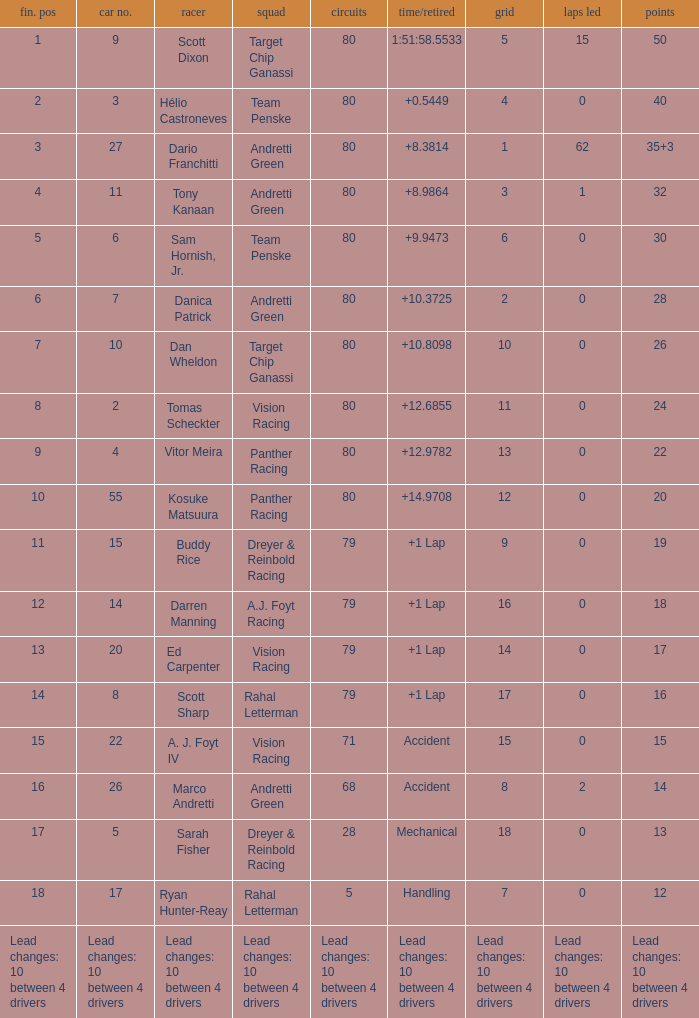How many laps does driver dario franchitti have? 80.0. Would you mind parsing the complete table? {'header': ['fin. pos', 'car no.', 'racer', 'squad', 'circuits', 'time/retired', 'grid', 'laps led', 'points'], 'rows': [['1', '9', 'Scott Dixon', 'Target Chip Ganassi', '80', '1:51:58.5533', '5', '15', '50'], ['2', '3', 'Hélio Castroneves', 'Team Penske', '80', '+0.5449', '4', '0', '40'], ['3', '27', 'Dario Franchitti', 'Andretti Green', '80', '+8.3814', '1', '62', '35+3'], ['4', '11', 'Tony Kanaan', 'Andretti Green', '80', '+8.9864', '3', '1', '32'], ['5', '6', 'Sam Hornish, Jr.', 'Team Penske', '80', '+9.9473', '6', '0', '30'], ['6', '7', 'Danica Patrick', 'Andretti Green', '80', '+10.3725', '2', '0', '28'], ['7', '10', 'Dan Wheldon', 'Target Chip Ganassi', '80', '+10.8098', '10', '0', '26'], ['8', '2', 'Tomas Scheckter', 'Vision Racing', '80', '+12.6855', '11', '0', '24'], ['9', '4', 'Vitor Meira', 'Panther Racing', '80', '+12.9782', '13', '0', '22'], ['10', '55', 'Kosuke Matsuura', 'Panther Racing', '80', '+14.9708', '12', '0', '20'], ['11', '15', 'Buddy Rice', 'Dreyer & Reinbold Racing', '79', '+1 Lap', '9', '0', '19'], ['12', '14', 'Darren Manning', 'A.J. Foyt Racing', '79', '+1 Lap', '16', '0', '18'], ['13', '20', 'Ed Carpenter', 'Vision Racing', '79', '+1 Lap', '14', '0', '17'], ['14', '8', 'Scott Sharp', 'Rahal Letterman', '79', '+1 Lap', '17', '0', '16'], ['15', '22', 'A. J. Foyt IV', 'Vision Racing', '71', 'Accident', '15', '0', '15'], ['16', '26', 'Marco Andretti', 'Andretti Green', '68', 'Accident', '8', '2', '14'], ['17', '5', 'Sarah Fisher', 'Dreyer & Reinbold Racing', '28', 'Mechanical', '18', '0', '13'], ['18', '17', 'Ryan Hunter-Reay', 'Rahal Letterman', '5', 'Handling', '7', '0', '12'], ['Lead changes: 10 between 4 drivers', 'Lead changes: 10 between 4 drivers', 'Lead changes: 10 between 4 drivers', 'Lead changes: 10 between 4 drivers', 'Lead changes: 10 between 4 drivers', 'Lead changes: 10 between 4 drivers', 'Lead changes: 10 between 4 drivers', 'Lead changes: 10 between 4 drivers', 'Lead changes: 10 between 4 drivers']]} 